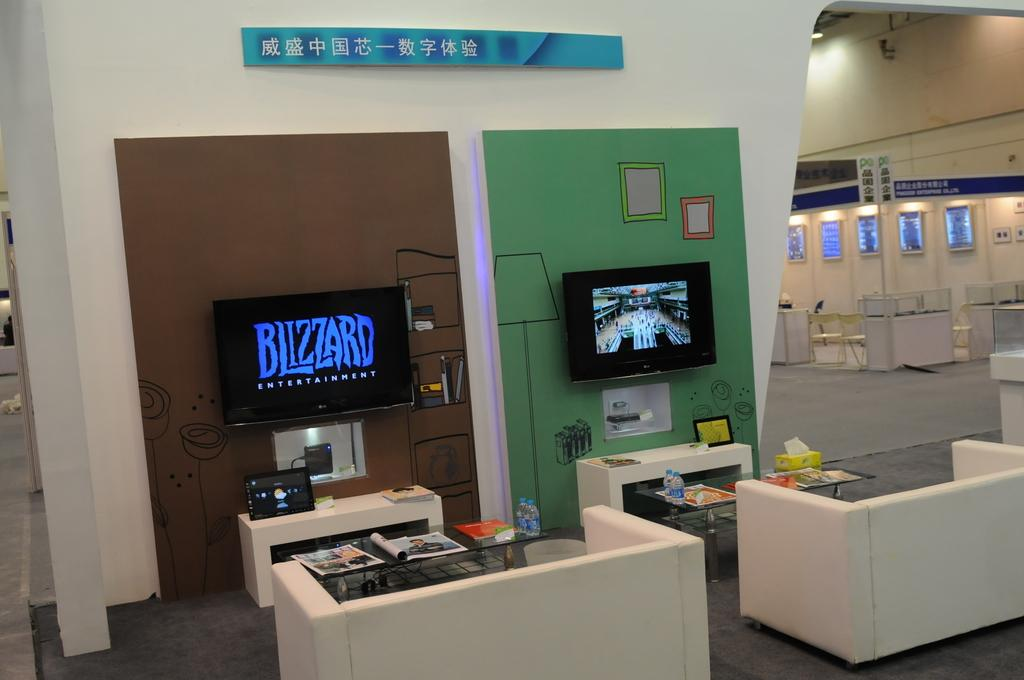What is the main object in the image? There is a screen in the image. What type of furniture is present in the image? There is a sofa and chairs in the image. What is on the table in the image? There are water bottles and papers on the table in the image. What is connected to the screen in the image? There is a cable wire connected to the screen in the image. What is on the floor in the image? There is a floor in the image. What is hanging on the wall in the image? There is a poster on the wall in the image. What is providing light in the image? There is a light in the image. What type of science experiment can be seen taking place on the tub in the image? There is no tub or science experiment present in the image. What is the reaction of the people in the image to the science experiment? There are no people or science experiment present in the image. 